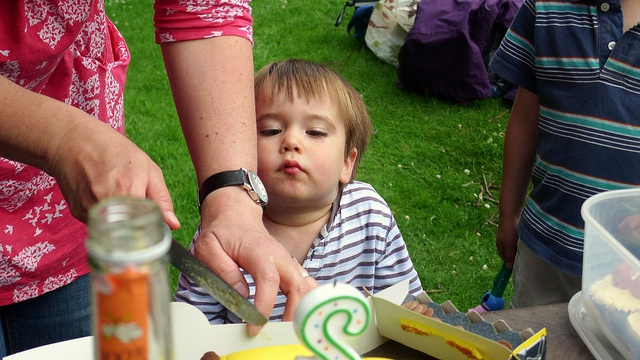Describe the objects in this image and their specific colors. I can see people in maroon, tan, and brown tones, people in maroon, black, gray, navy, and teal tones, people in maroon, gray, lightgray, and tan tones, bottle in maroon, darkgray, gray, brown, and red tones, and backpack in maroon, black, and purple tones in this image. 